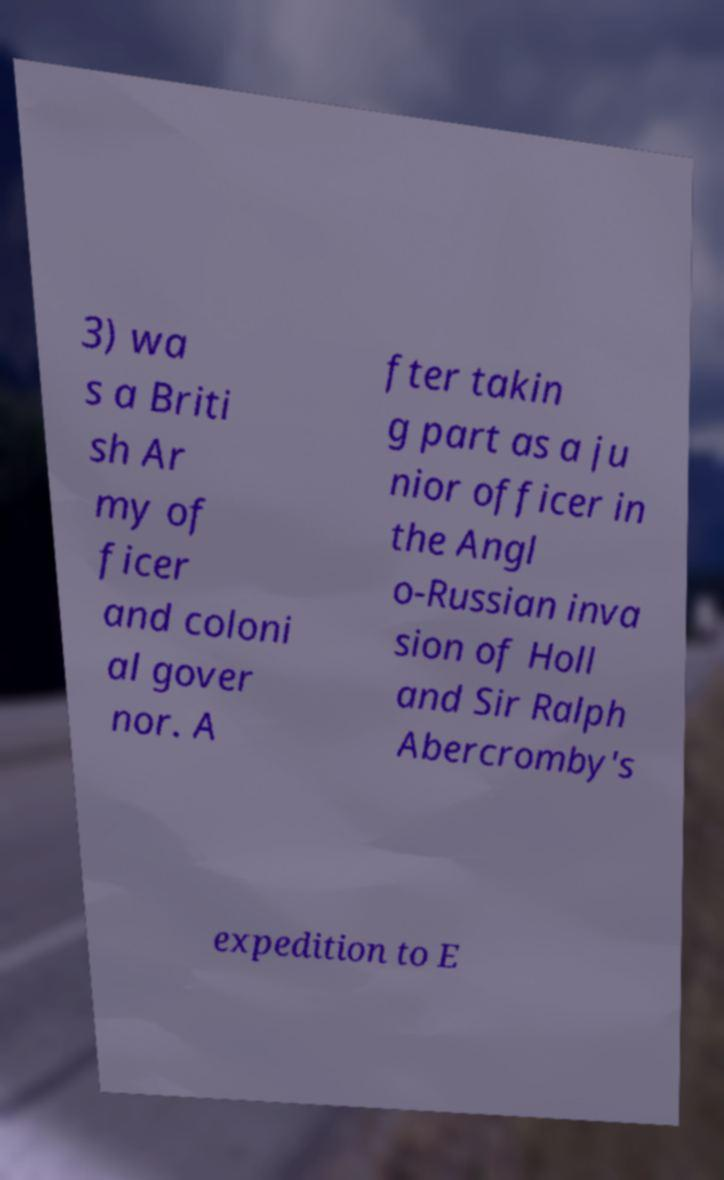Can you accurately transcribe the text from the provided image for me? 3) wa s a Briti sh Ar my of ficer and coloni al gover nor. A fter takin g part as a ju nior officer in the Angl o-Russian inva sion of Holl and Sir Ralph Abercromby's expedition to E 